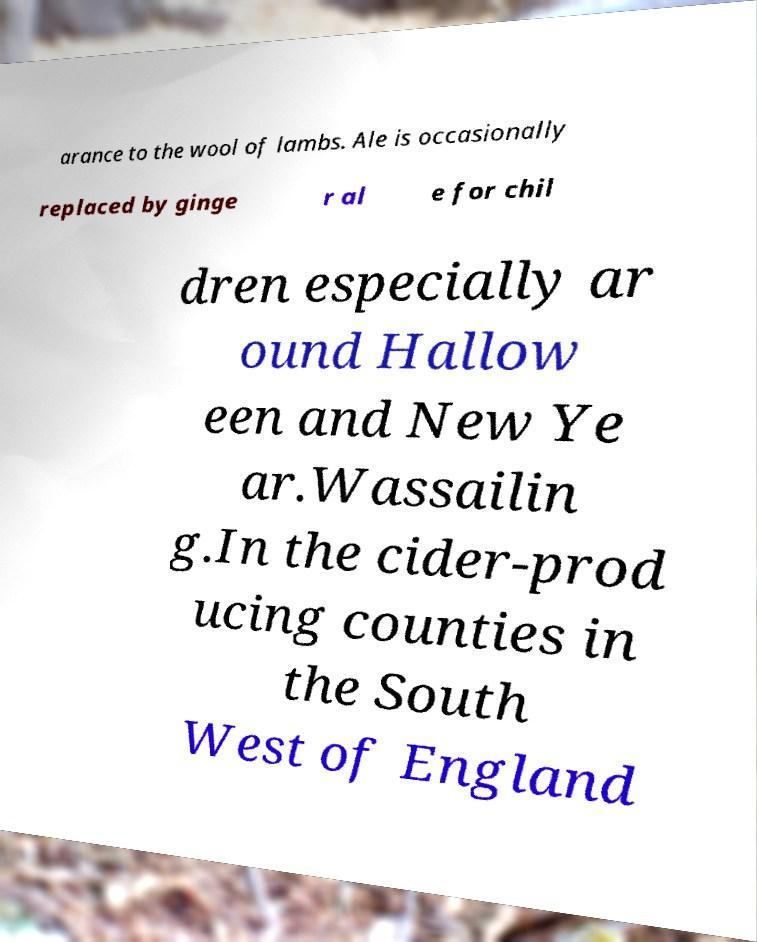Please read and relay the text visible in this image. What does it say? arance to the wool of lambs. Ale is occasionally replaced by ginge r al e for chil dren especially ar ound Hallow een and New Ye ar.Wassailin g.In the cider-prod ucing counties in the South West of England 